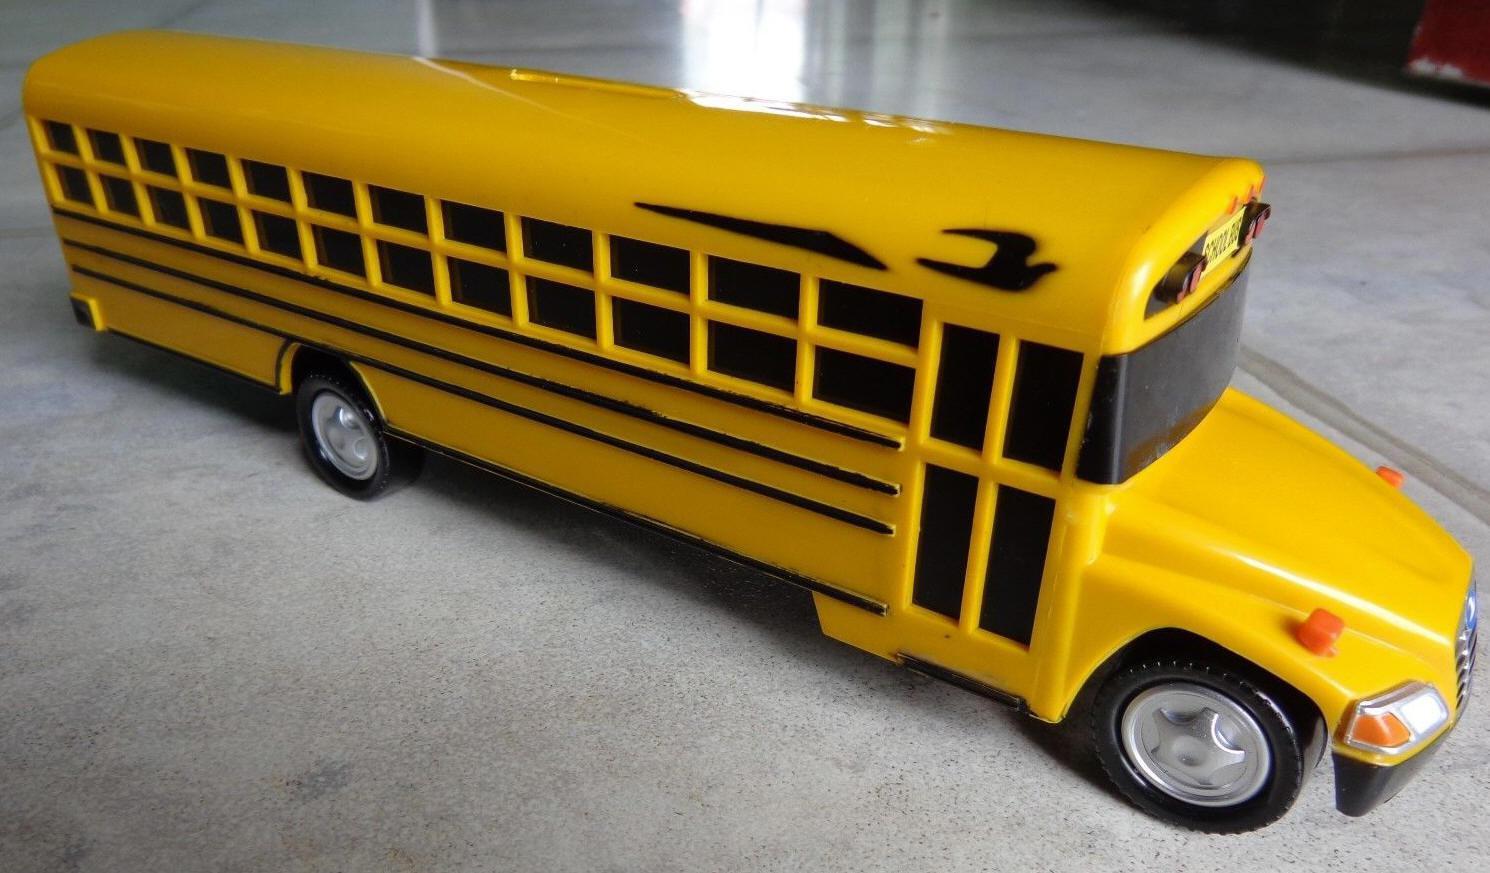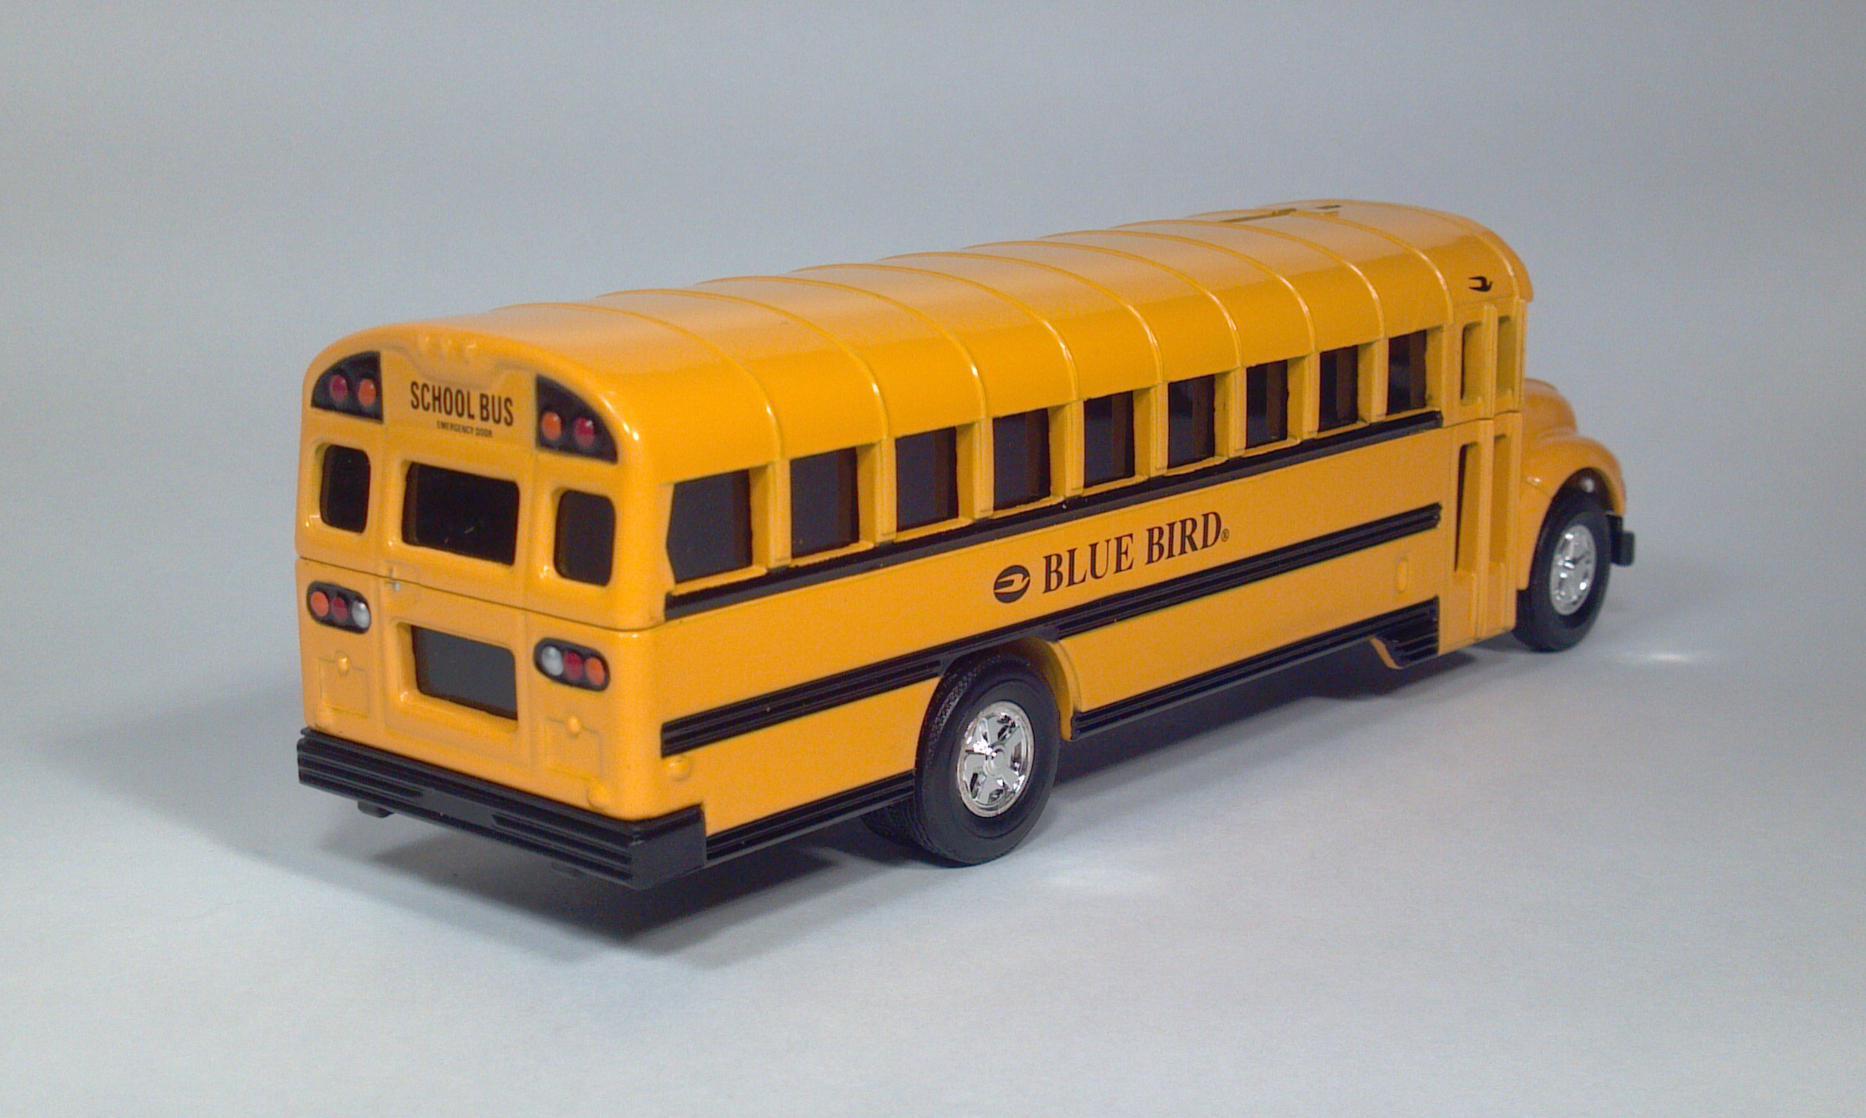The first image is the image on the left, the second image is the image on the right. For the images displayed, is the sentence "At least one bus has a red stop sign." factually correct? Answer yes or no. No. The first image is the image on the left, the second image is the image on the right. For the images shown, is this caption "A bus' left side is visible." true? Answer yes or no. No. 